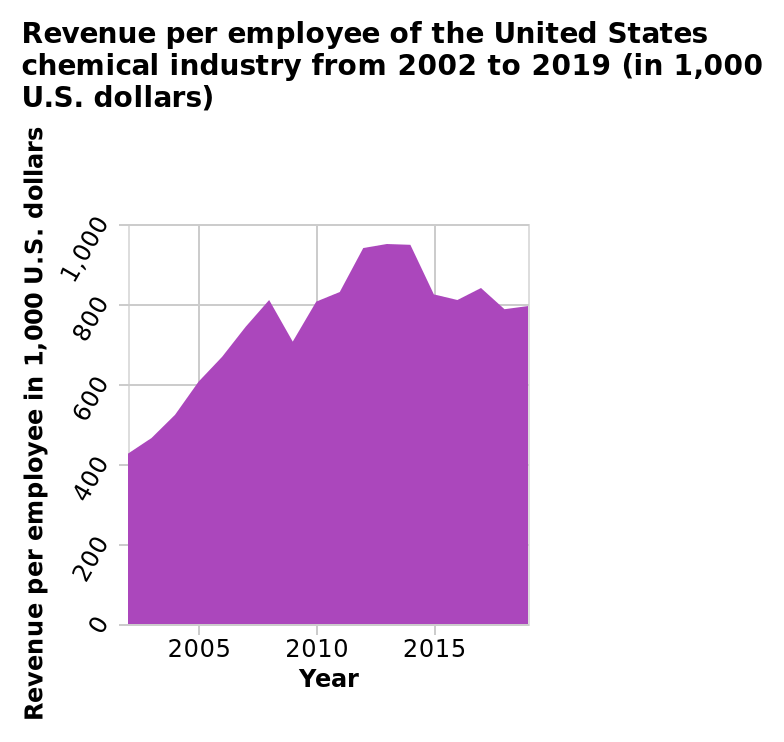<image>
What was the trend of the data from 2005 to 2010?  The data was increasing during this period. Did the data show a consistent pattern after 2010?  No, it fluctuated, going up and down. What is the range of the y-axis in the area chart?  The y-axis represents the revenue per employee in 1,000 U.S. dollars, with a linear scale from 0 to 1,000. 